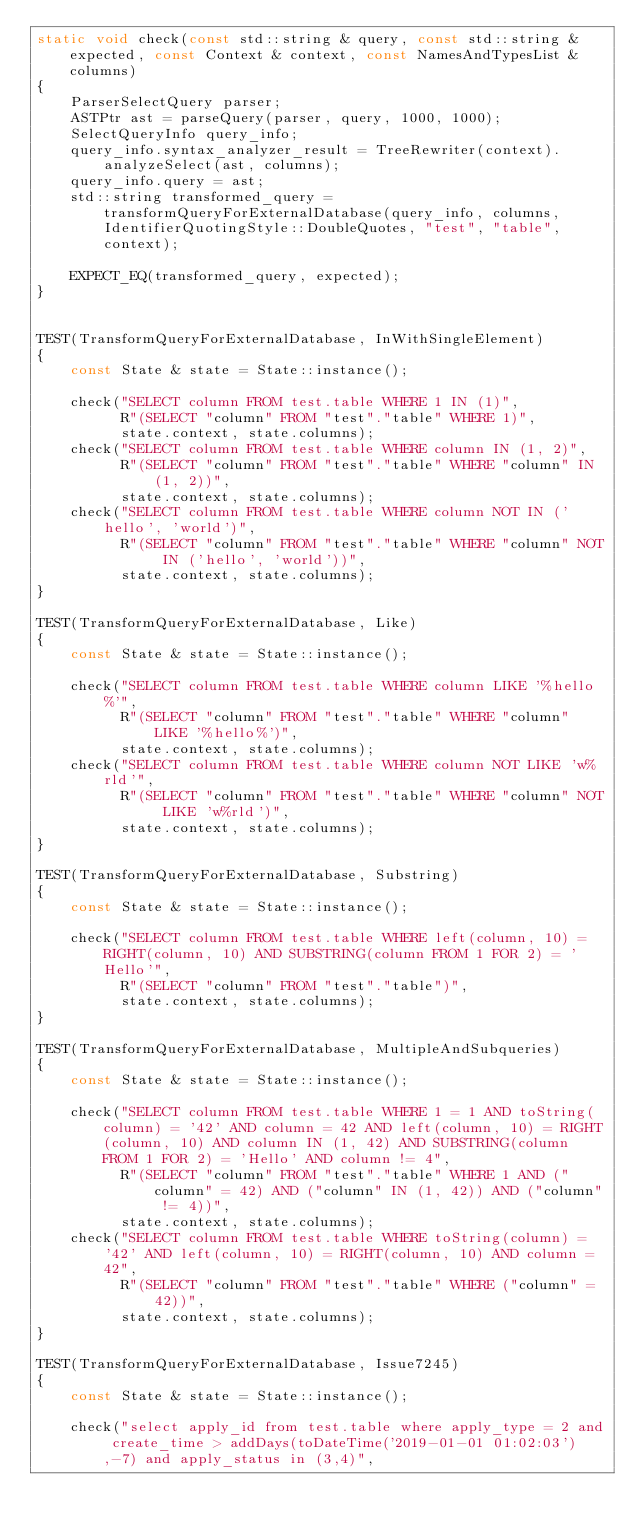<code> <loc_0><loc_0><loc_500><loc_500><_C++_>static void check(const std::string & query, const std::string & expected, const Context & context, const NamesAndTypesList & columns)
{
    ParserSelectQuery parser;
    ASTPtr ast = parseQuery(parser, query, 1000, 1000);
    SelectQueryInfo query_info;
    query_info.syntax_analyzer_result = TreeRewriter(context).analyzeSelect(ast, columns);
    query_info.query = ast;
    std::string transformed_query = transformQueryForExternalDatabase(query_info, columns, IdentifierQuotingStyle::DoubleQuotes, "test", "table", context);

    EXPECT_EQ(transformed_query, expected);
}


TEST(TransformQueryForExternalDatabase, InWithSingleElement)
{
    const State & state = State::instance();

    check("SELECT column FROM test.table WHERE 1 IN (1)",
          R"(SELECT "column" FROM "test"."table" WHERE 1)",
          state.context, state.columns);
    check("SELECT column FROM test.table WHERE column IN (1, 2)",
          R"(SELECT "column" FROM "test"."table" WHERE "column" IN (1, 2))",
          state.context, state.columns);
    check("SELECT column FROM test.table WHERE column NOT IN ('hello', 'world')",
          R"(SELECT "column" FROM "test"."table" WHERE "column" NOT IN ('hello', 'world'))",
          state.context, state.columns);
}

TEST(TransformQueryForExternalDatabase, Like)
{
    const State & state = State::instance();

    check("SELECT column FROM test.table WHERE column LIKE '%hello%'",
          R"(SELECT "column" FROM "test"."table" WHERE "column" LIKE '%hello%')",
          state.context, state.columns);
    check("SELECT column FROM test.table WHERE column NOT LIKE 'w%rld'",
          R"(SELECT "column" FROM "test"."table" WHERE "column" NOT LIKE 'w%rld')",
          state.context, state.columns);
}

TEST(TransformQueryForExternalDatabase, Substring)
{
    const State & state = State::instance();

    check("SELECT column FROM test.table WHERE left(column, 10) = RIGHT(column, 10) AND SUBSTRING(column FROM 1 FOR 2) = 'Hello'",
          R"(SELECT "column" FROM "test"."table")",
          state.context, state.columns);
}

TEST(TransformQueryForExternalDatabase, MultipleAndSubqueries)
{
    const State & state = State::instance();

    check("SELECT column FROM test.table WHERE 1 = 1 AND toString(column) = '42' AND column = 42 AND left(column, 10) = RIGHT(column, 10) AND column IN (1, 42) AND SUBSTRING(column FROM 1 FOR 2) = 'Hello' AND column != 4",
          R"(SELECT "column" FROM "test"."table" WHERE 1 AND ("column" = 42) AND ("column" IN (1, 42)) AND ("column" != 4))",
          state.context, state.columns);
    check("SELECT column FROM test.table WHERE toString(column) = '42' AND left(column, 10) = RIGHT(column, 10) AND column = 42",
          R"(SELECT "column" FROM "test"."table" WHERE ("column" = 42))",
          state.context, state.columns);
}

TEST(TransformQueryForExternalDatabase, Issue7245)
{
    const State & state = State::instance();

    check("select apply_id from test.table where apply_type = 2 and create_time > addDays(toDateTime('2019-01-01 01:02:03'),-7) and apply_status in (3,4)",</code> 